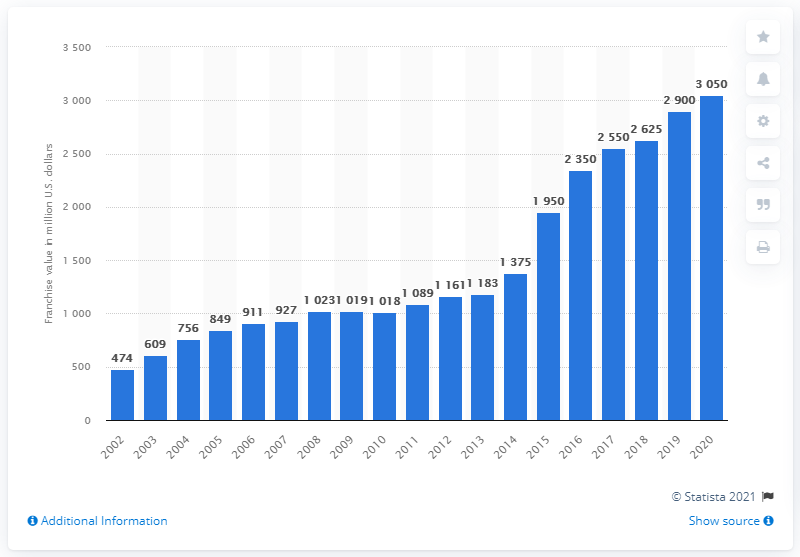Highlight a few significant elements in this photo. The franchise value of the Green Bay Packers in 2020 was reported to be 3,050. 